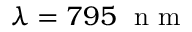<formula> <loc_0><loc_0><loc_500><loc_500>\lambda = 7 9 5 n m</formula> 